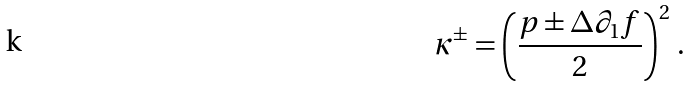Convert formula to latex. <formula><loc_0><loc_0><loc_500><loc_500>\kappa ^ { \pm } = \left ( \frac { p \pm \Delta \partial _ { 1 } f } { 2 } \right ) ^ { 2 } \, .</formula> 